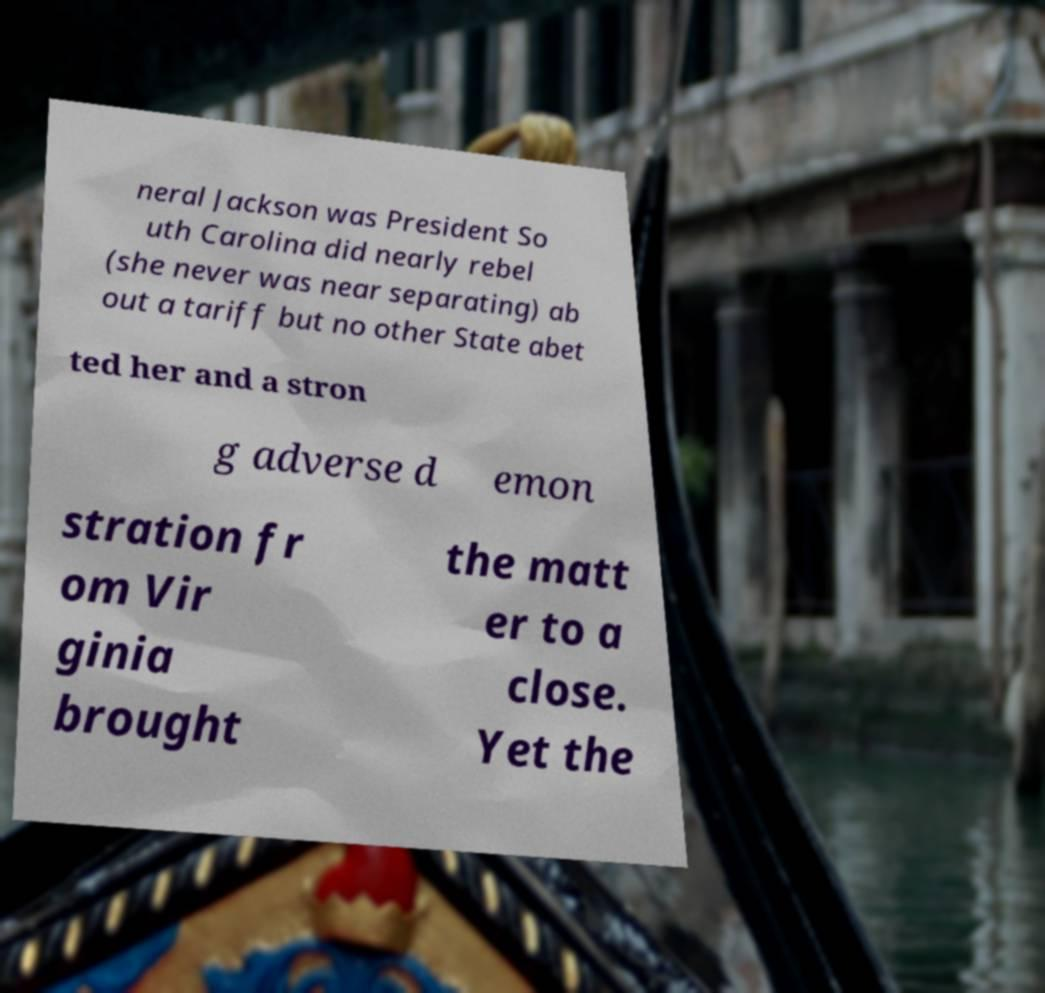Could you assist in decoding the text presented in this image and type it out clearly? neral Jackson was President So uth Carolina did nearly rebel (she never was near separating) ab out a tariff but no other State abet ted her and a stron g adverse d emon stration fr om Vir ginia brought the matt er to a close. Yet the 